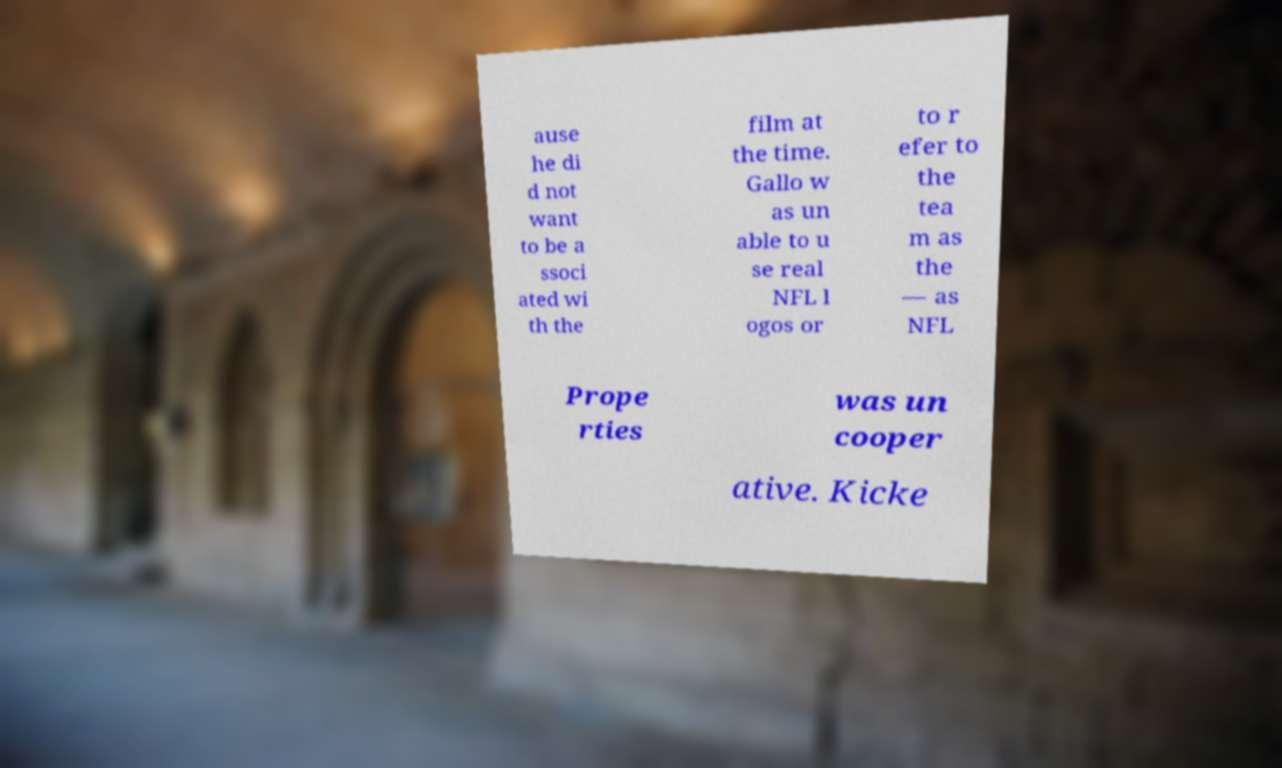Could you extract and type out the text from this image? ause he di d not want to be a ssoci ated wi th the film at the time. Gallo w as un able to u se real NFL l ogos or to r efer to the tea m as the — as NFL Prope rties was un cooper ative. Kicke 